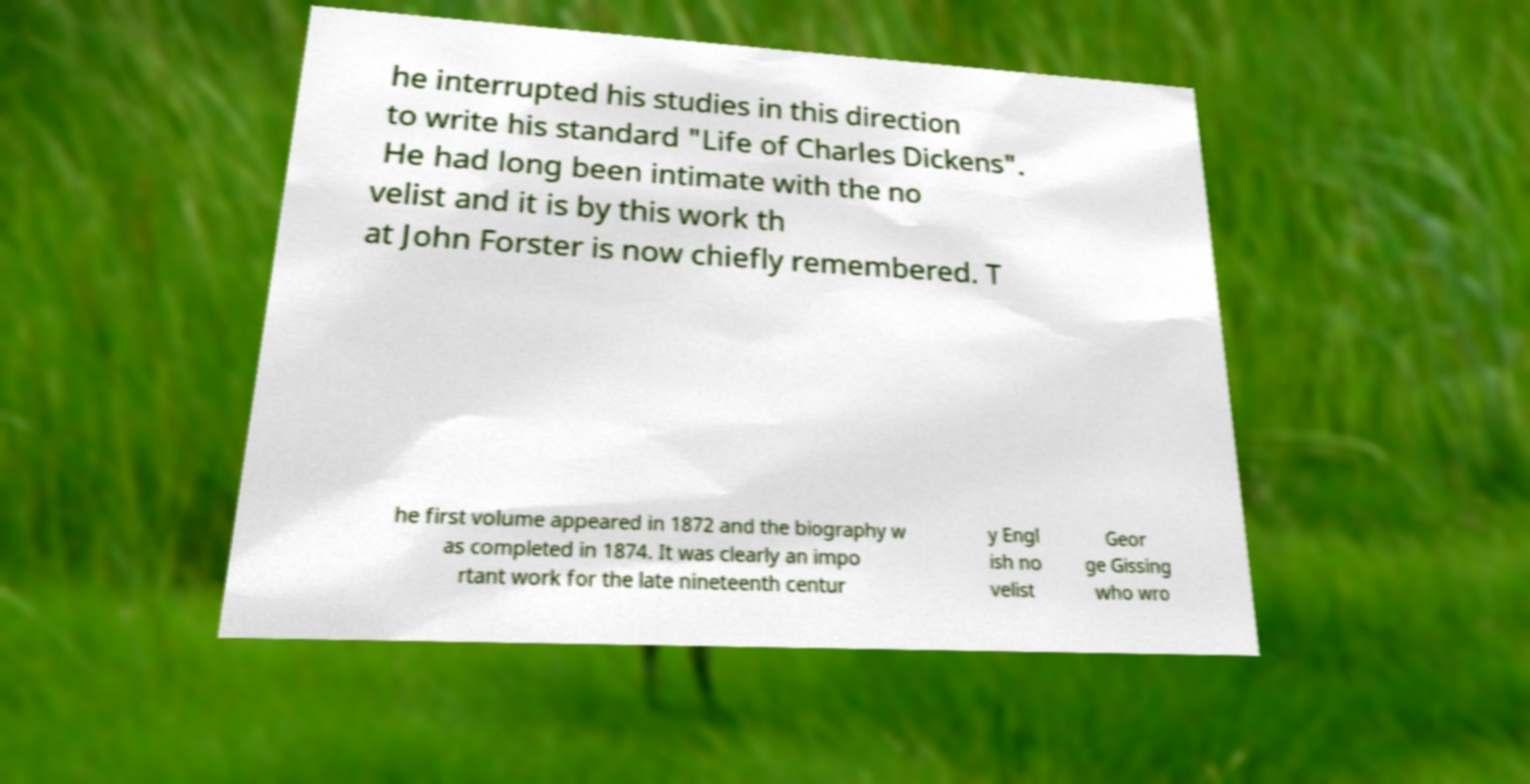Can you read and provide the text displayed in the image?This photo seems to have some interesting text. Can you extract and type it out for me? he interrupted his studies in this direction to write his standard "Life of Charles Dickens". He had long been intimate with the no velist and it is by this work th at John Forster is now chiefly remembered. T he first volume appeared in 1872 and the biography w as completed in 1874. It was clearly an impo rtant work for the late nineteenth centur y Engl ish no velist Geor ge Gissing who wro 